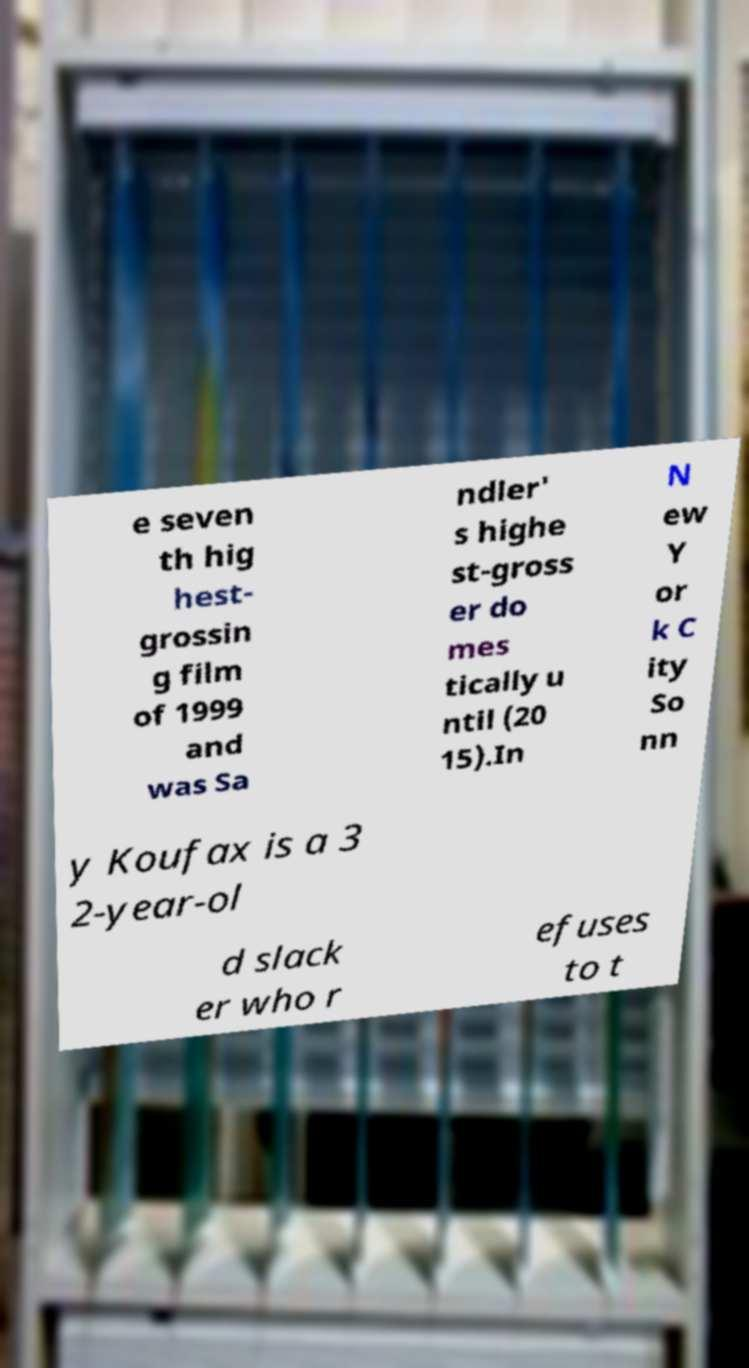I need the written content from this picture converted into text. Can you do that? e seven th hig hest- grossin g film of 1999 and was Sa ndler' s highe st-gross er do mes tically u ntil (20 15).In N ew Y or k C ity So nn y Koufax is a 3 2-year-ol d slack er who r efuses to t 